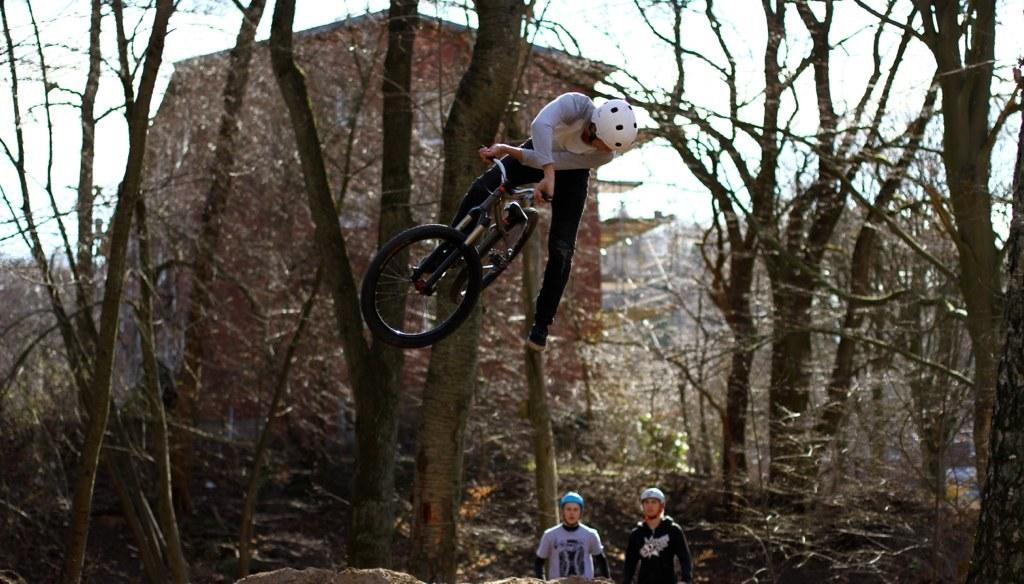How many people are in the image? There are people in the image, but the exact number is not specified. What is located in the foreground of the image? There is a bicycle in the foreground of the image. What type of vegetation is present in the image? There are dry trees in the image. What can be seen in the background of the image? There appears to be a building in the background of the image. What is visible at the top of the image? The sky is visible at the top of the image. Can you see a truck driving through the sea in the image? No, there is no truck or sea present in the image. 